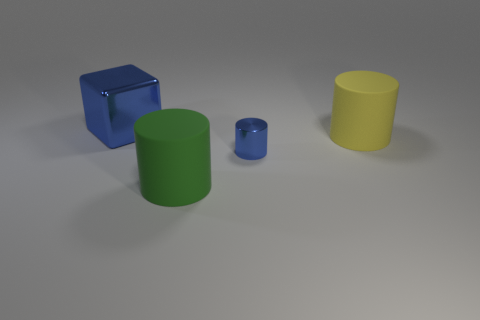Are there any other things that are the same size as the blue cylinder?
Give a very brief answer. No. Is the metal cube the same color as the metallic cylinder?
Provide a succinct answer. Yes. What color is the object that is on the right side of the big green cylinder and behind the small blue shiny object?
Your response must be concise. Yellow. There is a blue thing that is to the right of the cube; is it the same size as the blue metal object on the left side of the blue metallic cylinder?
Make the answer very short. No. How many other objects are the same size as the blue metallic cylinder?
Offer a terse response. 0. How many cylinders are to the left of the big thing that is on the right side of the large green cylinder?
Provide a succinct answer. 2. Are there fewer large metallic things on the right side of the large blue shiny cube than big cylinders?
Keep it short and to the point. Yes. There is a thing that is to the right of the metal thing in front of the big cylinder that is behind the small object; what shape is it?
Ensure brevity in your answer.  Cylinder. Do the small thing and the big green matte object have the same shape?
Make the answer very short. Yes. What number of other objects are there of the same shape as the large metal object?
Offer a very short reply. 0. 